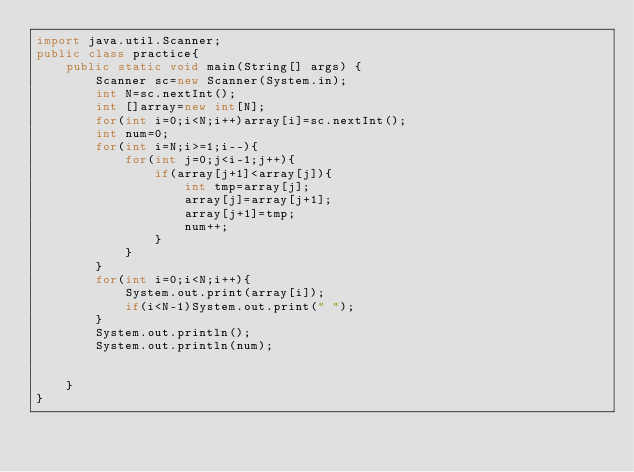<code> <loc_0><loc_0><loc_500><loc_500><_Java_>import java.util.Scanner;
public class practice{
    public static void main(String[] args) {
        Scanner sc=new Scanner(System.in);
        int N=sc.nextInt();
        int []array=new int[N];
        for(int i=0;i<N;i++)array[i]=sc.nextInt();
        int num=0;
        for(int i=N;i>=1;i--){
            for(int j=0;j<i-1;j++){
                if(array[j+1]<array[j]){
                    int tmp=array[j];
                    array[j]=array[j+1];
                    array[j+1]=tmp;
                    num++;
                }
            }
        }
        for(int i=0;i<N;i++){
            System.out.print(array[i]);
            if(i<N-1)System.out.print(" ");
        }
        System.out.println();
        System.out.println(num);

        
    }
}
</code> 